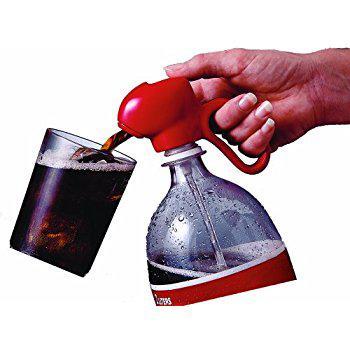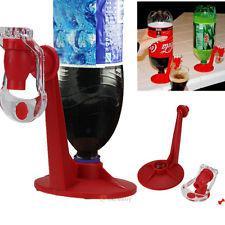The first image is the image on the left, the second image is the image on the right. Considering the images on both sides, is "One of the soda bottles is green." valid? Answer yes or no. Yes. 